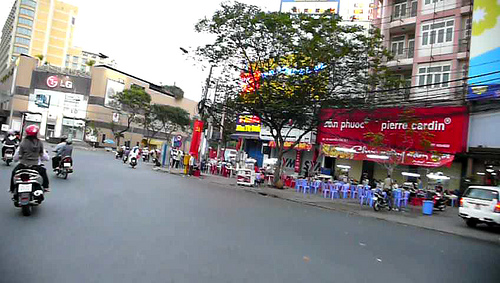Is there a bag in the picture? No, there is no visible bag in the picture. 